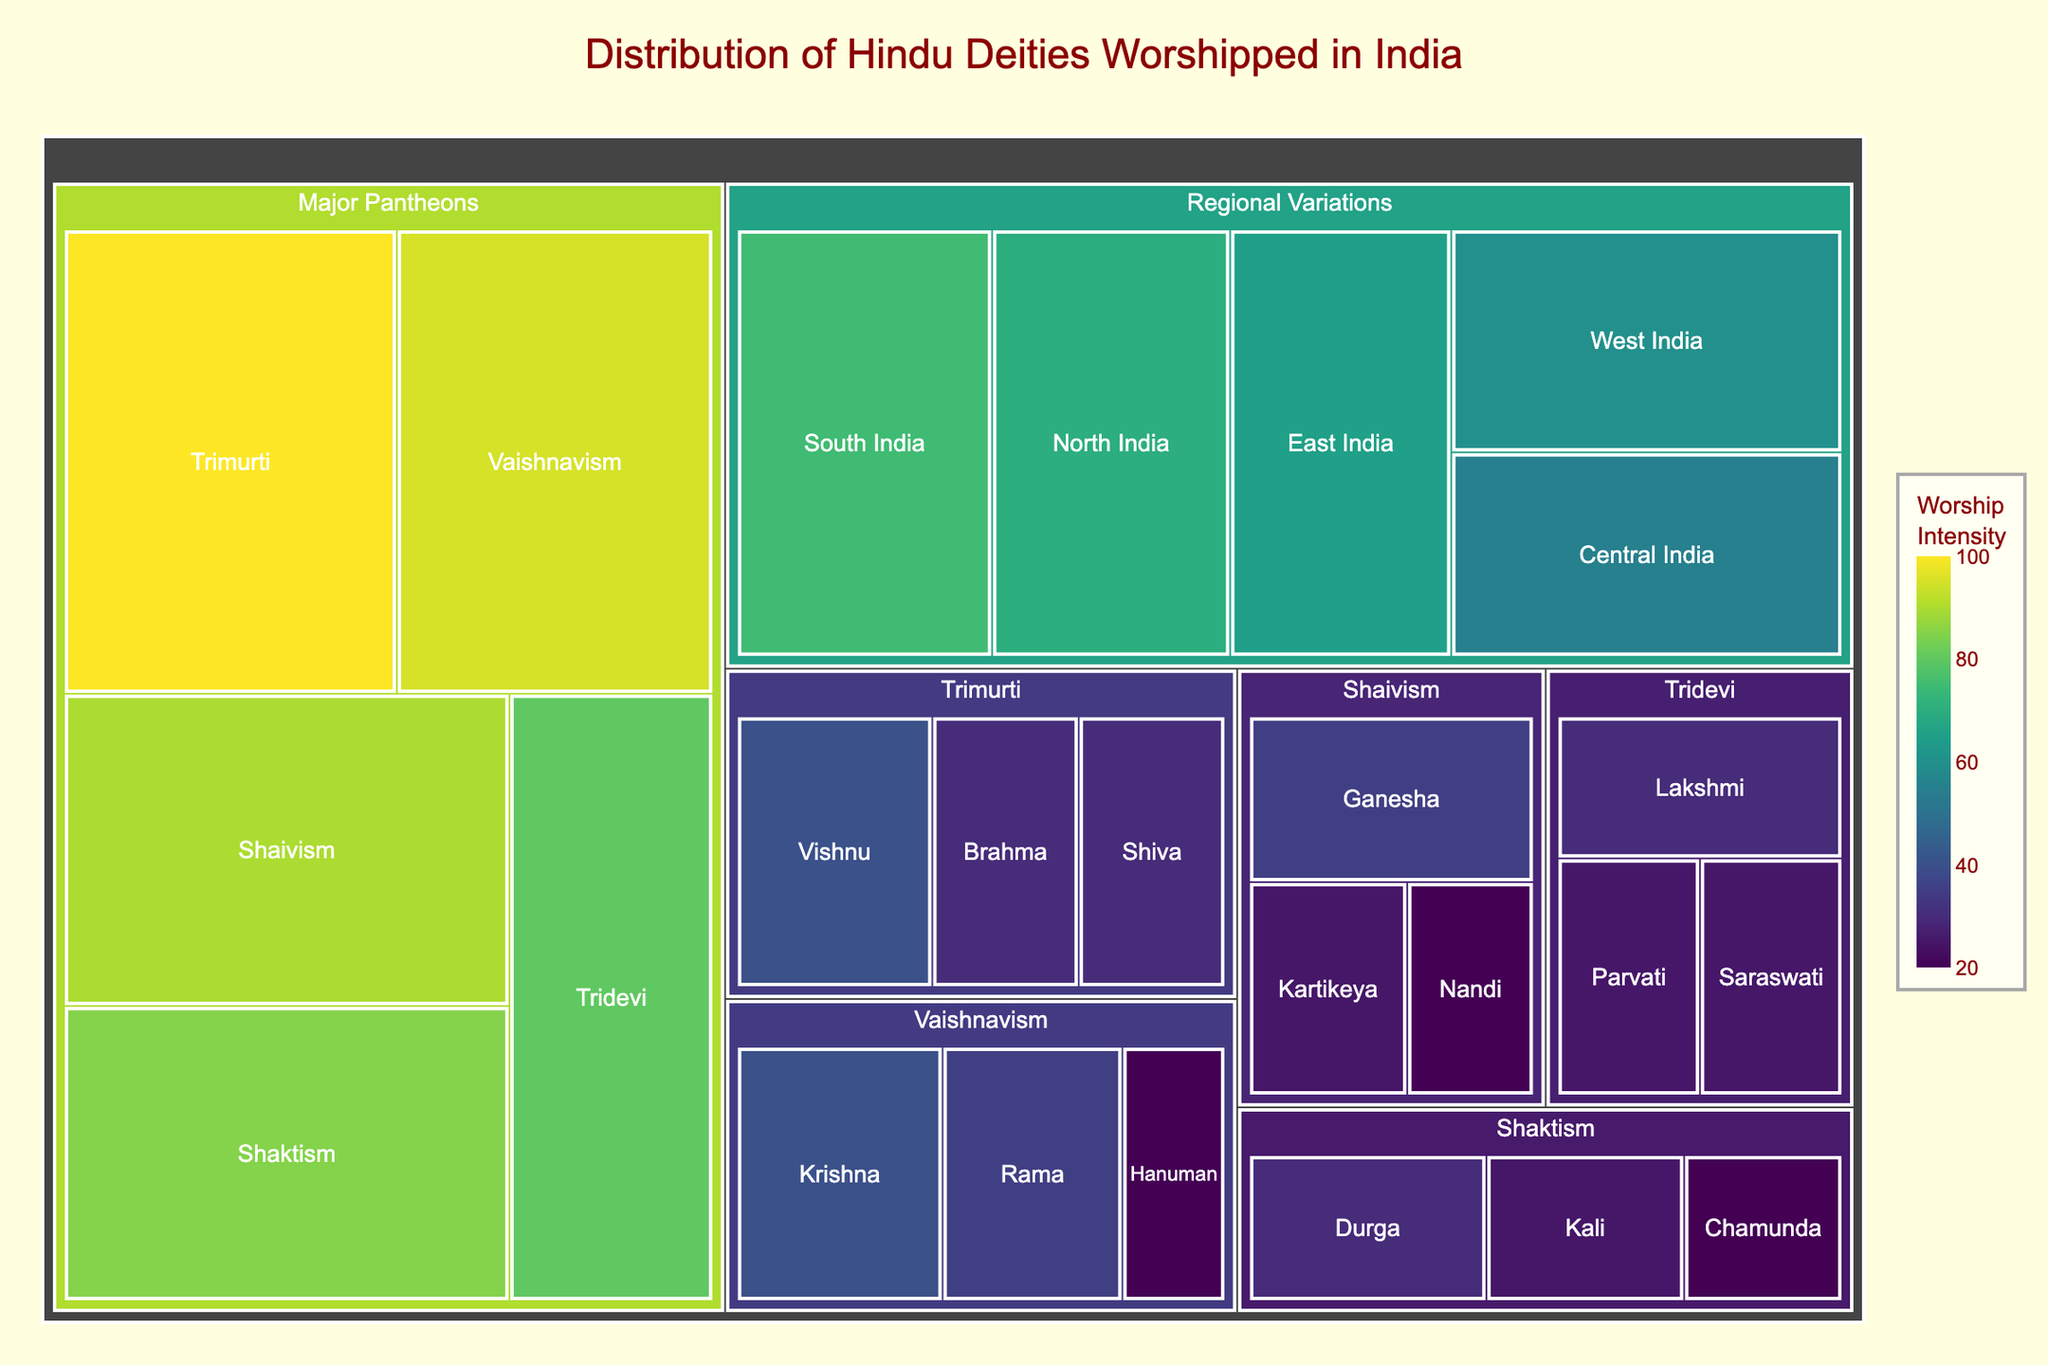What is the title of the Treemap? The title is generally located at the top of the chart and is often the largest text. It describes the main topic of the Treemap.
Answer: Distribution of Hindu Deities Worshipped in India Which subcategory under Major Pantheons has the highest worship intensity? To find this, look at the segments under "Major Pantheons" and identify the one with the highest value.
Answer: Trimurti How many regions are represented under Regional Variations? Count the number of distinct segments within the "Regional Variations" category.
Answer: 5 What is the total worship intensity for the Trimurti deities? Add the values of Brahma, Vishnu, and Shiva under the Trimurti subcategory. 30 + 40 + 30 = 100
Answer: 100 Which deity in the Shaivism category has the lowest value? Look at the values for the deities under "Shaivism" and find the smallest one.
Answer: Nandi Compare the worship intensity of North India and South India under Regional Variations. Which one is greater? Compare the values of "North India" and "South India" segments. South India (75) is greater than North India (70).
Answer: South India What is the sum of values for the deities under Tridevi? Add the values of Saraswati, Lakshmi, and Parvati. 25 + 30 + 25 = 80
Answer: 80 Between Shaktism and Shaivism, which has the higher total worship intensity? Calculate the sum of values for each category:
Shaktism: 30 + 25 + 20 = 75
Shaivism: 35 + 25 + 20 = 80
Shaivism has a higher total.
Answer: Shaivism Which deity has the highest individual worship intensity? Identify the highest value from all the deities in the Treemap.
Answer: Vishnu What's the average worship intensity for the deities under Vaishnavism? Calculate the average by adding the values of Krishna, Rama, and Hanuman, then dividing by the number of deities. (40 + 35 + 20) / 3 = 95 / 3 ≈ 31.67
Answer: 31.67 